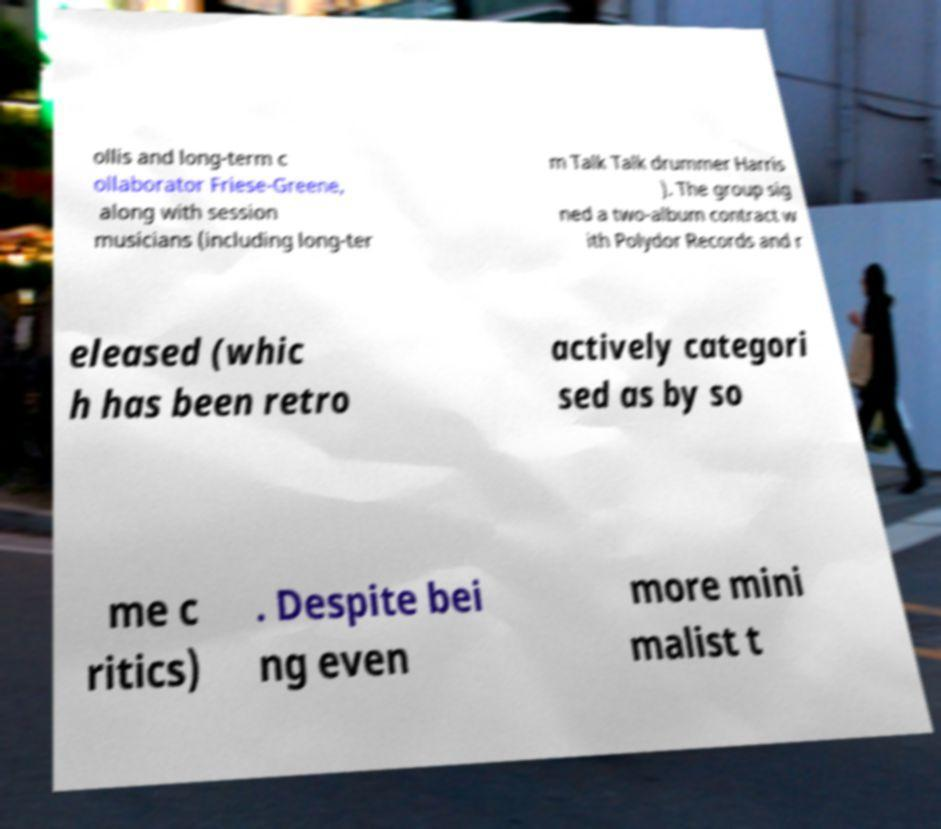Could you extract and type out the text from this image? ollis and long-term c ollaborator Friese-Greene, along with session musicians (including long-ter m Talk Talk drummer Harris ). The group sig ned a two-album contract w ith Polydor Records and r eleased (whic h has been retro actively categori sed as by so me c ritics) . Despite bei ng even more mini malist t 